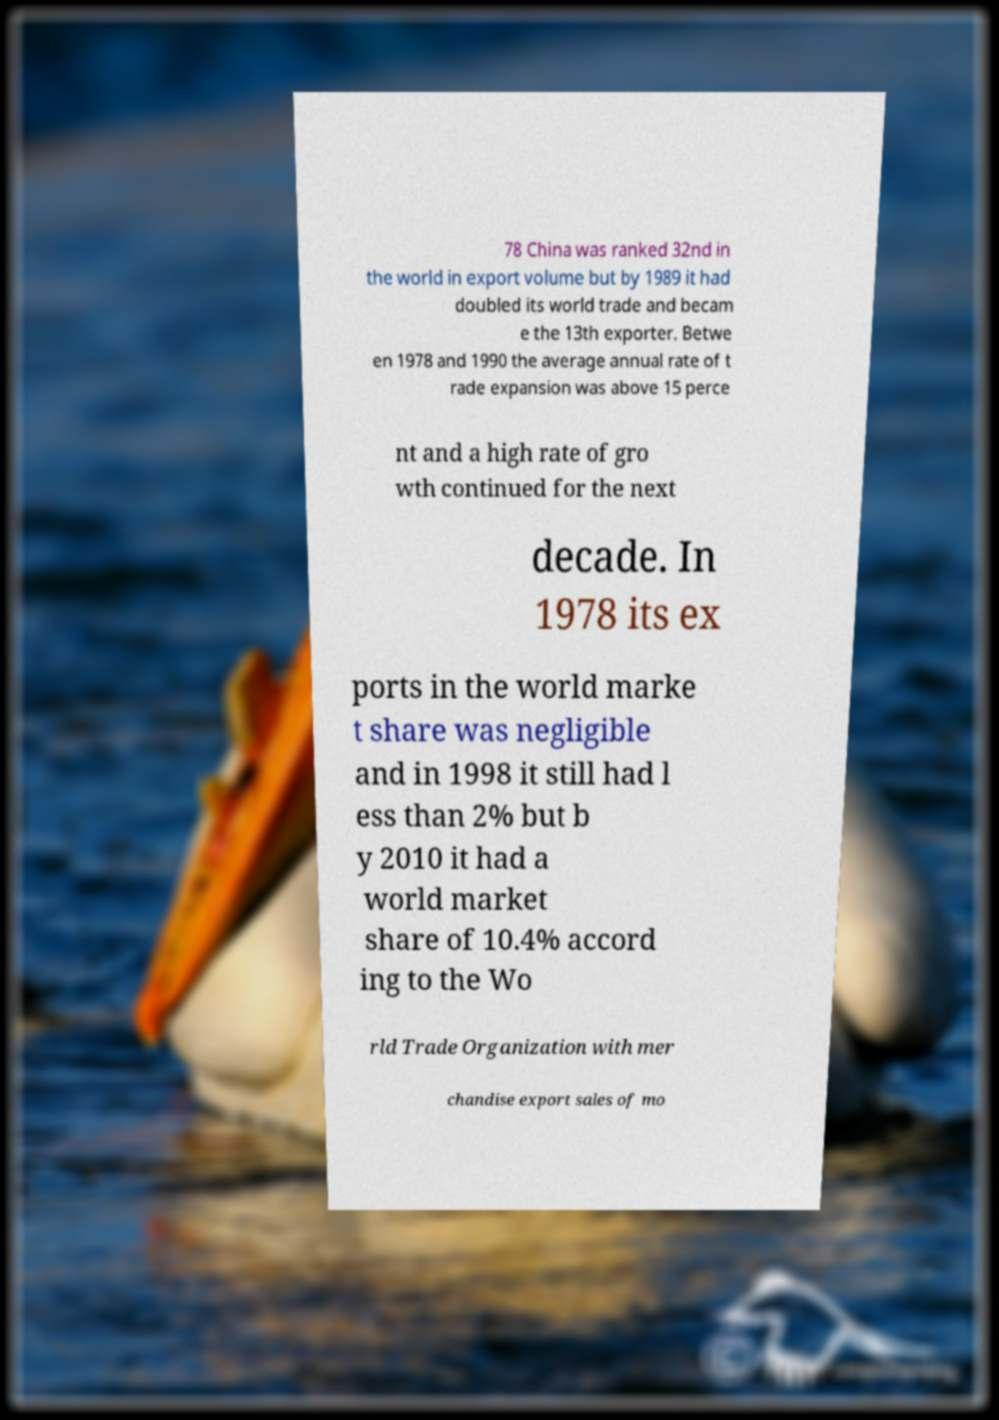Can you accurately transcribe the text from the provided image for me? 78 China was ranked 32nd in the world in export volume but by 1989 it had doubled its world trade and becam e the 13th exporter. Betwe en 1978 and 1990 the average annual rate of t rade expansion was above 15 perce nt and a high rate of gro wth continued for the next decade. In 1978 its ex ports in the world marke t share was negligible and in 1998 it still had l ess than 2% but b y 2010 it had a world market share of 10.4% accord ing to the Wo rld Trade Organization with mer chandise export sales of mo 